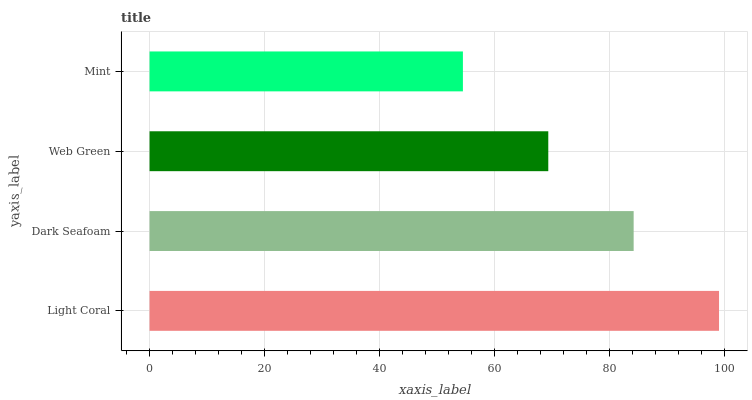Is Mint the minimum?
Answer yes or no. Yes. Is Light Coral the maximum?
Answer yes or no. Yes. Is Dark Seafoam the minimum?
Answer yes or no. No. Is Dark Seafoam the maximum?
Answer yes or no. No. Is Light Coral greater than Dark Seafoam?
Answer yes or no. Yes. Is Dark Seafoam less than Light Coral?
Answer yes or no. Yes. Is Dark Seafoam greater than Light Coral?
Answer yes or no. No. Is Light Coral less than Dark Seafoam?
Answer yes or no. No. Is Dark Seafoam the high median?
Answer yes or no. Yes. Is Web Green the low median?
Answer yes or no. Yes. Is Web Green the high median?
Answer yes or no. No. Is Dark Seafoam the low median?
Answer yes or no. No. 